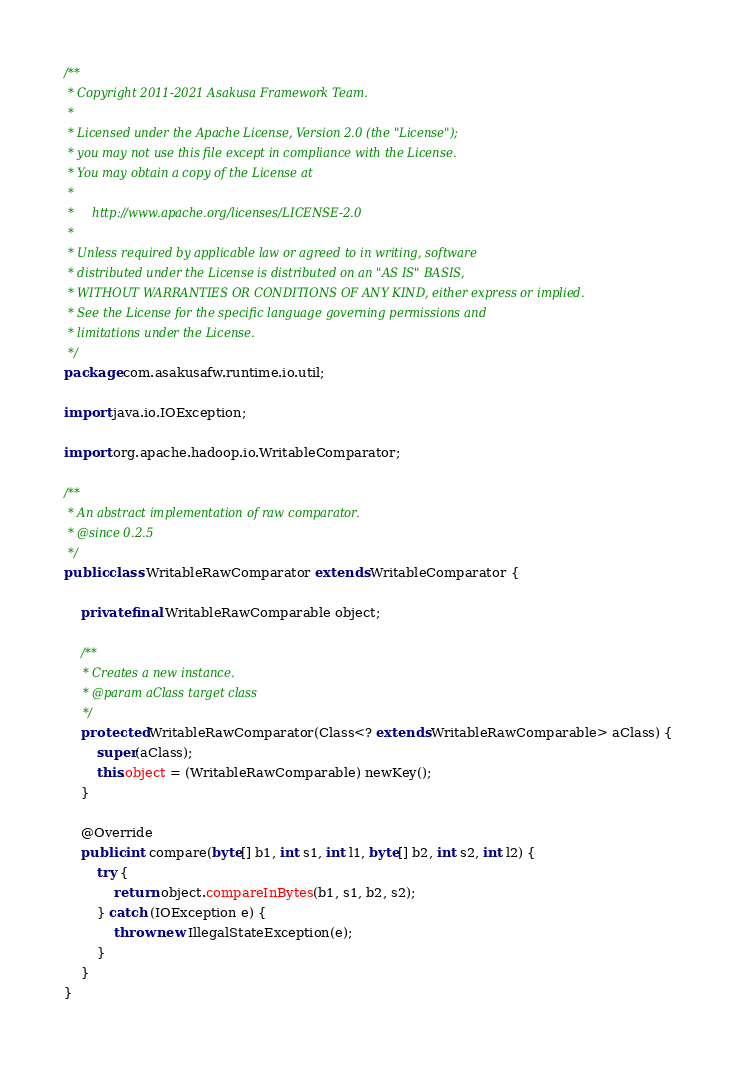Convert code to text. <code><loc_0><loc_0><loc_500><loc_500><_Java_>/**
 * Copyright 2011-2021 Asakusa Framework Team.
 *
 * Licensed under the Apache License, Version 2.0 (the "License");
 * you may not use this file except in compliance with the License.
 * You may obtain a copy of the License at
 *
 *     http://www.apache.org/licenses/LICENSE-2.0
 *
 * Unless required by applicable law or agreed to in writing, software
 * distributed under the License is distributed on an "AS IS" BASIS,
 * WITHOUT WARRANTIES OR CONDITIONS OF ANY KIND, either express or implied.
 * See the License for the specific language governing permissions and
 * limitations under the License.
 */
package com.asakusafw.runtime.io.util;

import java.io.IOException;

import org.apache.hadoop.io.WritableComparator;

/**
 * An abstract implementation of raw comparator.
 * @since 0.2.5
 */
public class WritableRawComparator extends WritableComparator {

    private final WritableRawComparable object;

    /**
     * Creates a new instance.
     * @param aClass target class
     */
    protected WritableRawComparator(Class<? extends WritableRawComparable> aClass) {
        super(aClass);
        this.object = (WritableRawComparable) newKey();
    }

    @Override
    public int compare(byte[] b1, int s1, int l1, byte[] b2, int s2, int l2) {
        try {
            return object.compareInBytes(b1, s1, b2, s2);
        } catch (IOException e) {
            throw new IllegalStateException(e);
        }
    }
}
</code> 